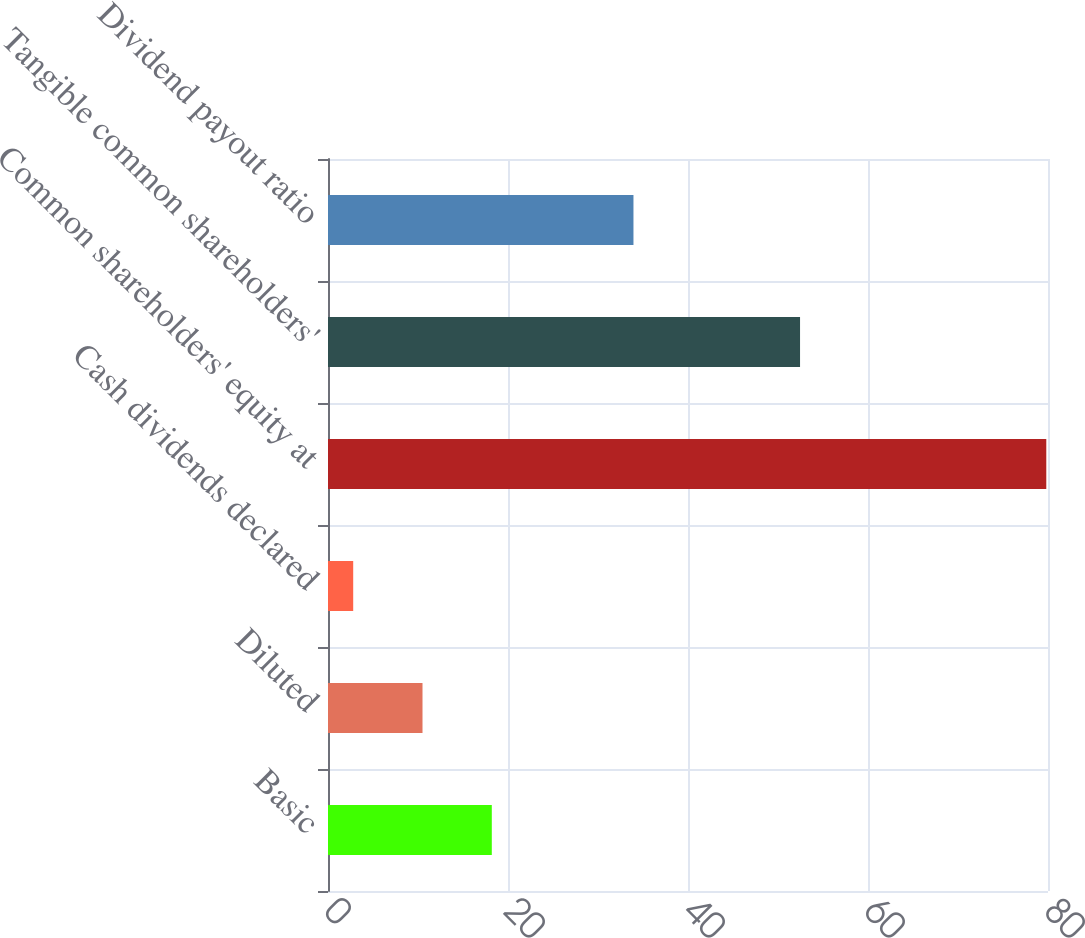Convert chart. <chart><loc_0><loc_0><loc_500><loc_500><bar_chart><fcel>Basic<fcel>Diluted<fcel>Cash dividends declared<fcel>Common shareholders' equity at<fcel>Tangible common shareholders'<fcel>Dividend payout ratio<nl><fcel>18.2<fcel>10.5<fcel>2.8<fcel>79.81<fcel>52.45<fcel>33.94<nl></chart> 